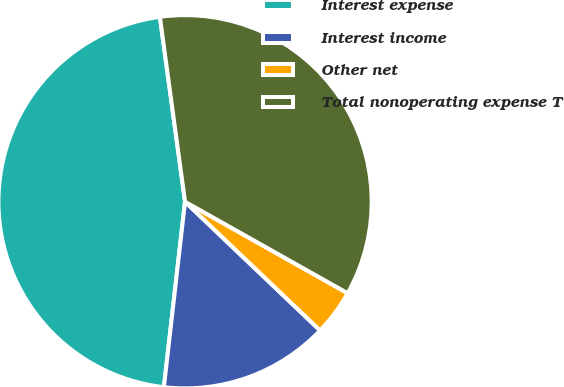Convert chart to OTSL. <chart><loc_0><loc_0><loc_500><loc_500><pie_chart><fcel>Interest expense<fcel>Interest income<fcel>Other net<fcel>Total nonoperating expense T<nl><fcel>46.04%<fcel>14.69%<fcel>3.96%<fcel>35.31%<nl></chart> 